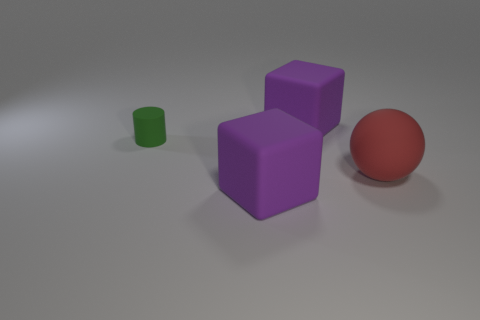Add 2 big matte things. How many objects exist? 6 Subtract all balls. How many objects are left? 3 Add 2 big rubber objects. How many big rubber objects exist? 5 Subtract 0 yellow spheres. How many objects are left? 4 Subtract all green things. Subtract all red balls. How many objects are left? 2 Add 1 large rubber spheres. How many large rubber spheres are left? 2 